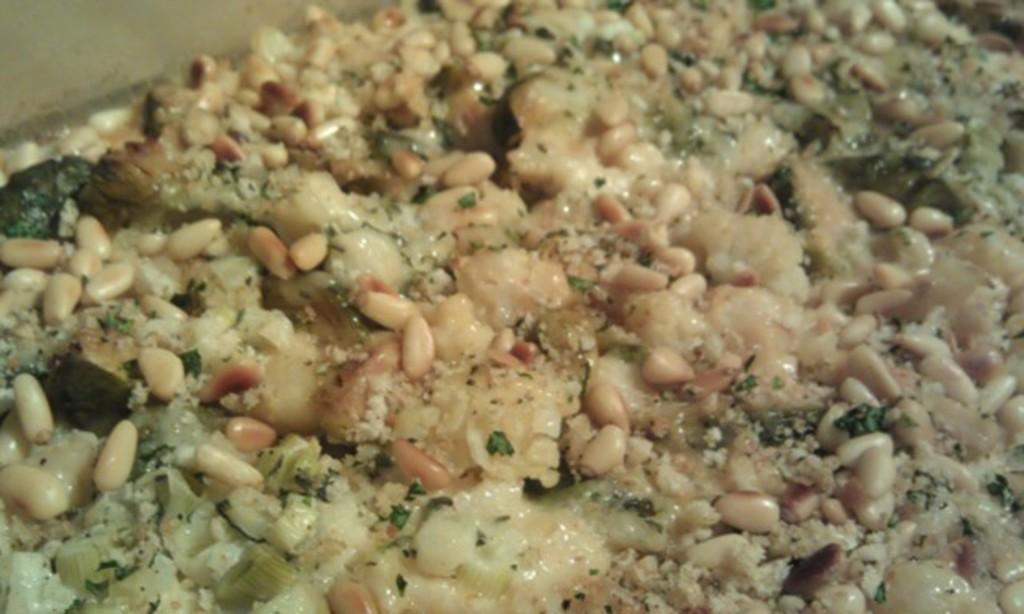What is present in the image? There is food in the image. Can you describe the food in the image? Unfortunately, the provided facts do not give any specific details about the food. Is there any context or setting provided for the food in the image? No, the only fact given is that there is food in the image. What type of locket is hanging from the food in the image? There is no locket present in the image, as the only fact given is that there is food in the image. 